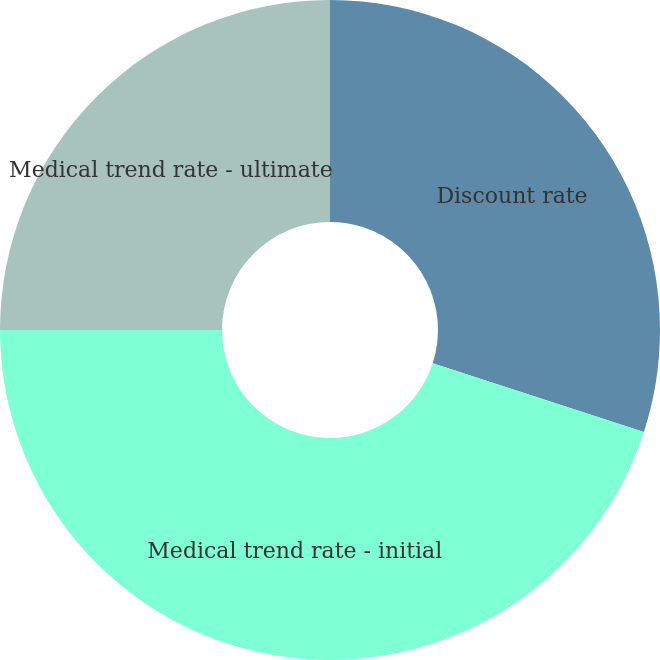Convert chart. <chart><loc_0><loc_0><loc_500><loc_500><pie_chart><fcel>Discount rate<fcel>Medical trend rate - initial<fcel>Medical trend rate - ultimate<nl><fcel>30.0%<fcel>45.0%<fcel>25.0%<nl></chart> 